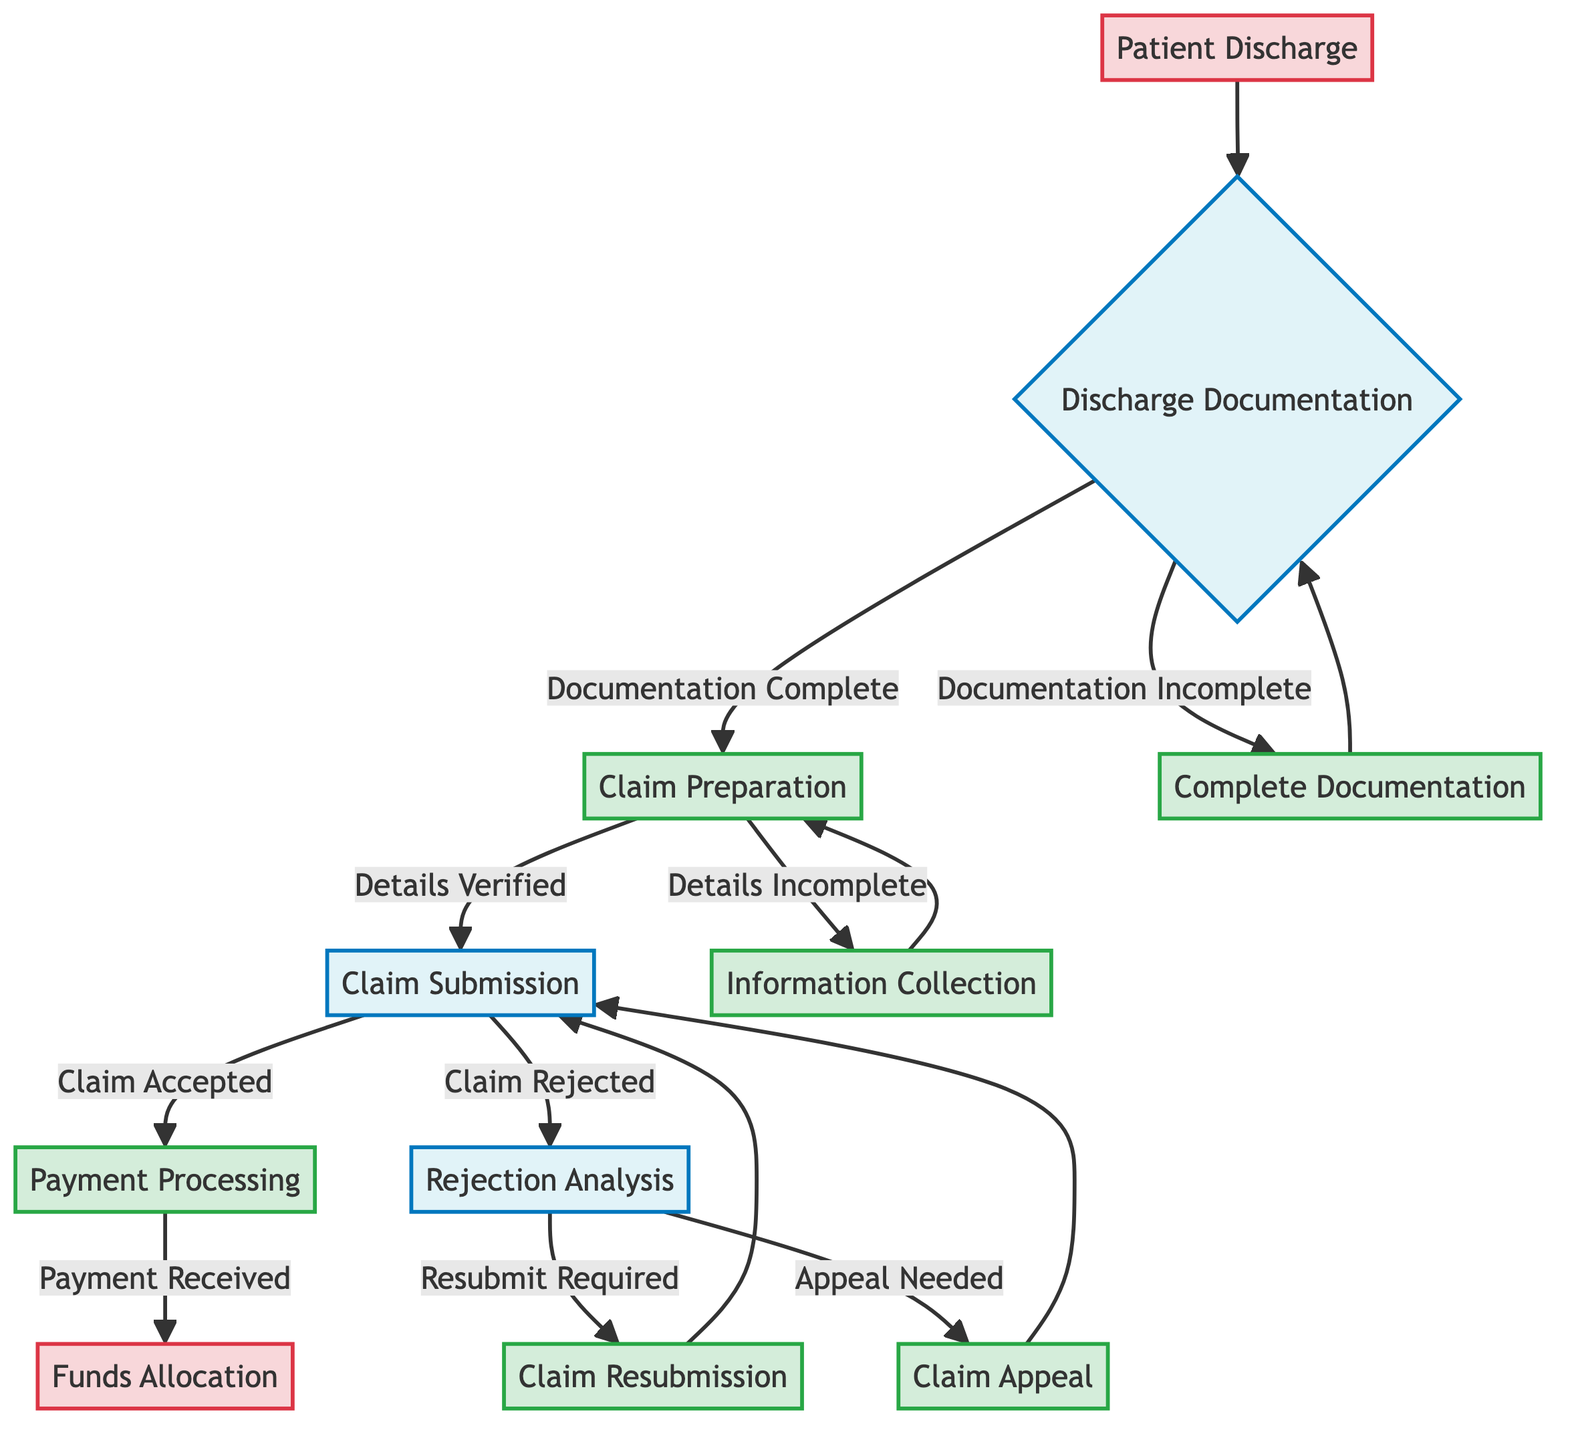What is the starting point of the decision tree? The starting point in the decision tree is labeled as "Patient Discharge."
Answer: Patient Discharge How many primary steps are there after "Discharge Documentation"? After "Discharge Documentation," there are two primary steps: "Claim Preparation" and "Complete Documentation." Counting both options, the total is two.
Answer: 2 What happens if the documentation is incomplete? If the documentation is incomplete, the next step is "Complete Documentation." This involves gathering the required discharge documentation to ensure its completeness.
Answer: Complete Documentation What is the action taken if the claim is accepted? If the claim is accepted, the next action taken is "Payment Processing," where the insurance provider processes the payment to the hospital.
Answer: Payment Processing What follows after a "Claim Rejection"? After a "Claim Rejection," the next step involves "Rejection Analysis" to analyze the reasons for rejection. Subsequently, it may lead to either "Claim Resubmission" or "Claim Appeal."
Answer: Rejection Analysis What must be verified before submitting a claim? Before submitting a claim, the details must be verified as complete. This is part of the "Claim Preparation" step.
Answer: Details Verified If additional information is needed for a rejected claim, what is the next course of action? If additional information is needed after a claim rejection, the next course of action is to perform "Rejection Analysis" to understand the rejection reasons.
Answer: Rejection Analysis How many conditions are there under "Claim Submission"? Under "Claim Submission," there are two conditions: "Claim Accepted" and "Claim Rejected," making a total of two conditions.
Answer: 2 What occurs after the payment is received? After the payment is received, the next step is "Funds Allocation," where the received funds are allocated to the appropriate hospital accounts.
Answer: Funds Allocation 